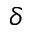Convert formula to latex. <formula><loc_0><loc_0><loc_500><loc_500>\delta</formula> 